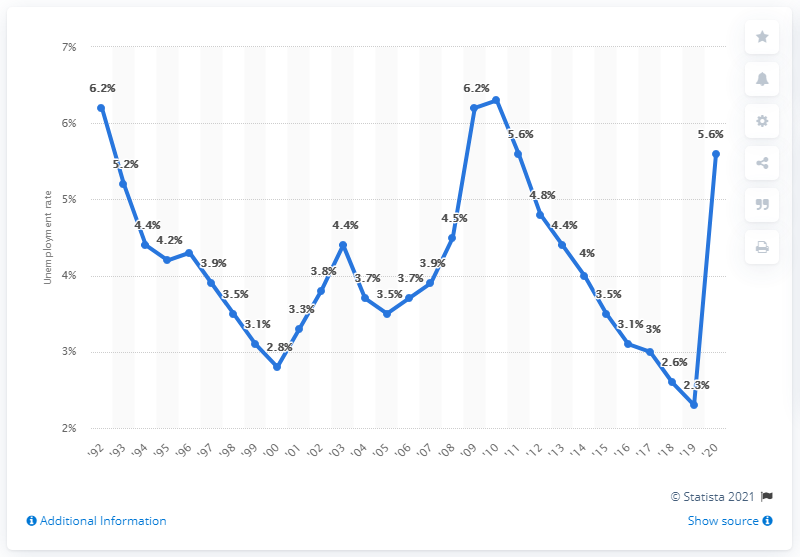Point out several critical features in this image. In 2010, the unemployment rate in Vermont reached its highest level at 6.3%. In 2010, the unemployment rate in Vermont was 2.3%. In 2020, the unemployment rate in Vermont was 5.6%. 